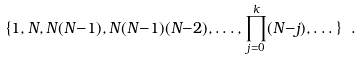<formula> <loc_0><loc_0><loc_500><loc_500>\{ { 1 , N , N ( N { - } 1 ) , N ( N { - } 1 ) ( N { - } 2 ) , \dots , \prod _ { j = 0 } ^ { k } ( N { - } j ) , \dots \} } \ .</formula> 